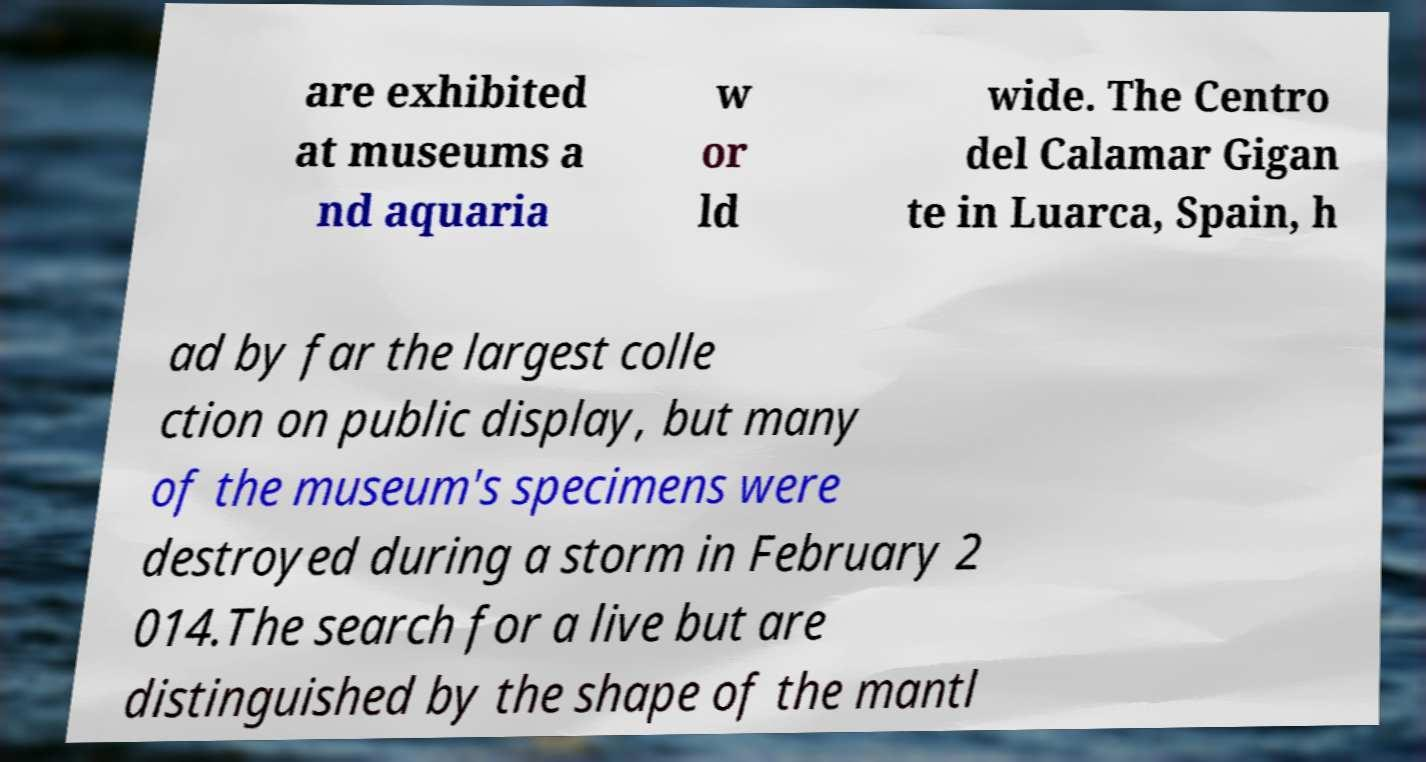Please identify and transcribe the text found in this image. are exhibited at museums a nd aquaria w or ld wide. The Centro del Calamar Gigan te in Luarca, Spain, h ad by far the largest colle ction on public display, but many of the museum's specimens were destroyed during a storm in February 2 014.The search for a live but are distinguished by the shape of the mantl 